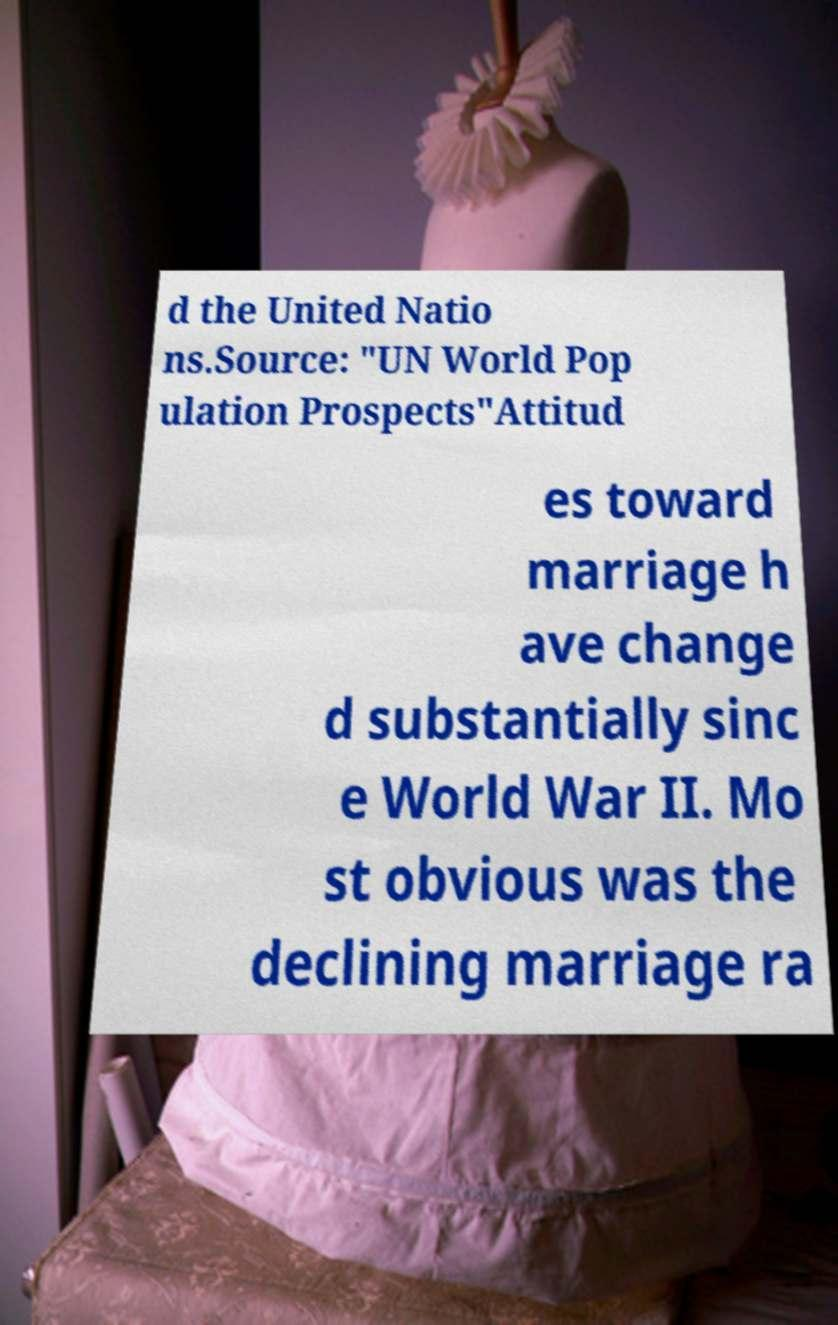Could you assist in decoding the text presented in this image and type it out clearly? d the United Natio ns.Source: "UN World Pop ulation Prospects"Attitud es toward marriage h ave change d substantially sinc e World War II. Mo st obvious was the declining marriage ra 